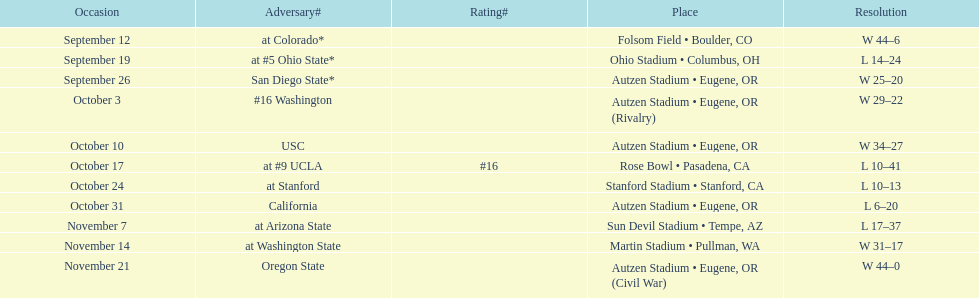Were the results of the game of november 14 above or below the results of the october 17 game? Above. 